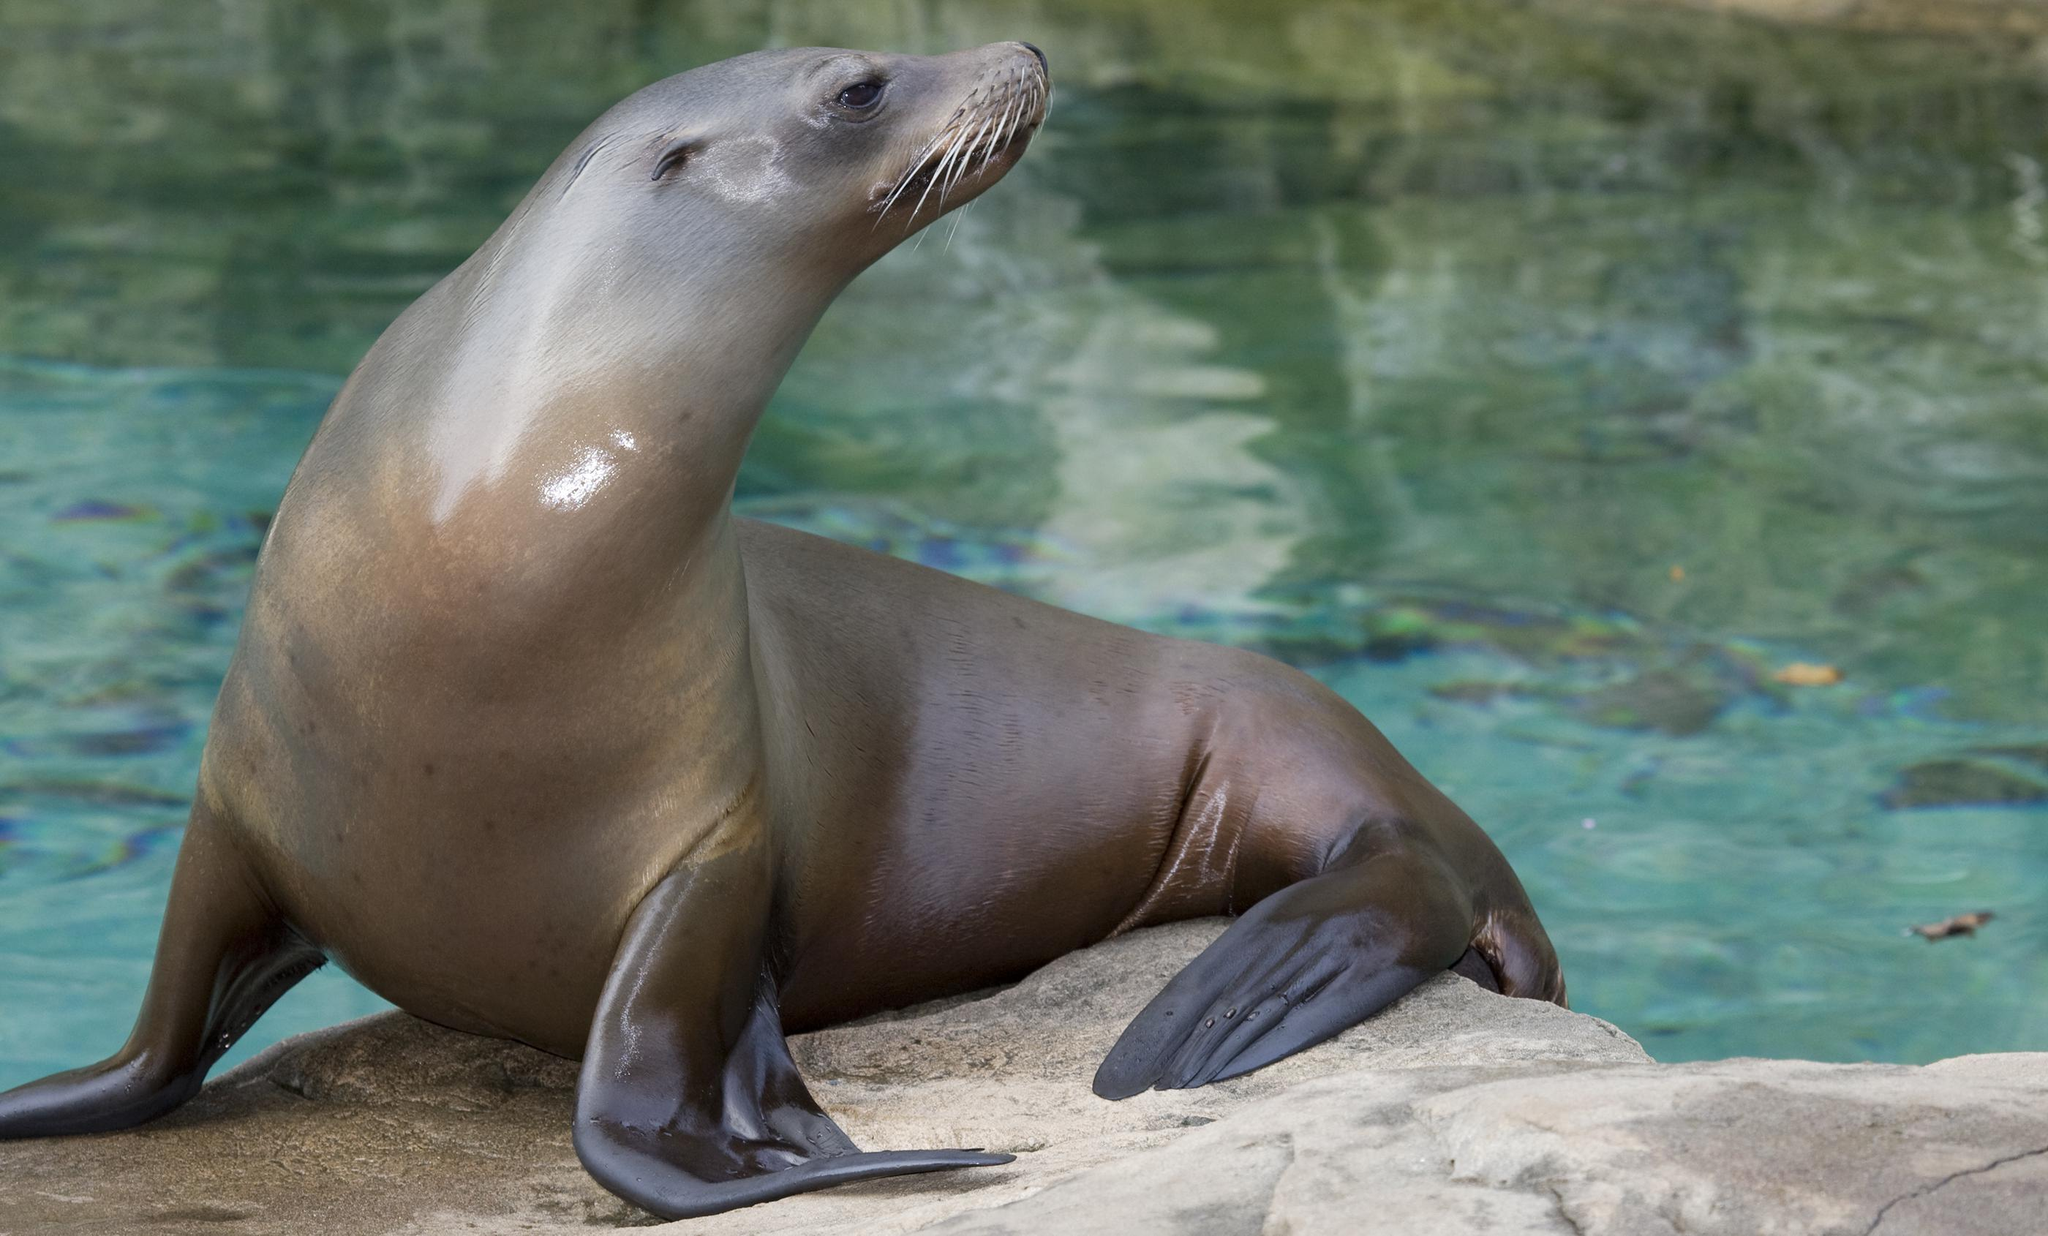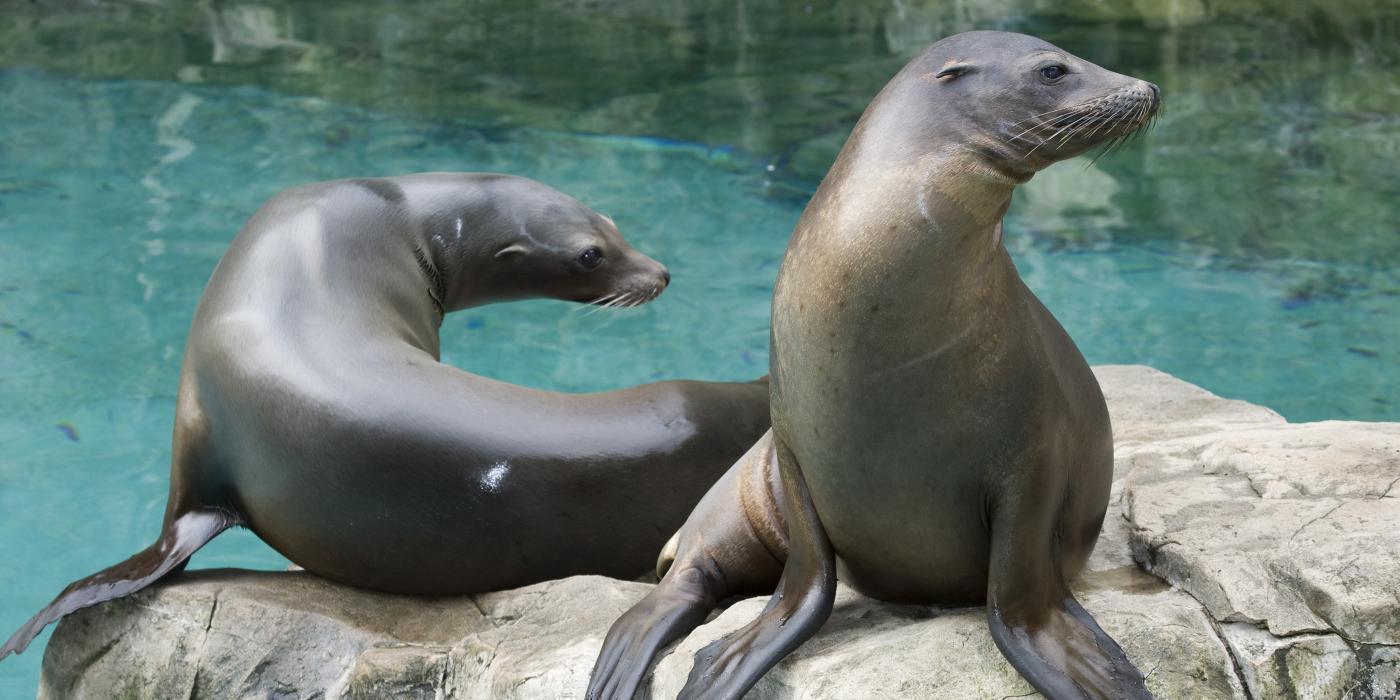The first image is the image on the left, the second image is the image on the right. For the images shown, is this caption "One or more seals are sitting on a rock in both images." true? Answer yes or no. Yes. 